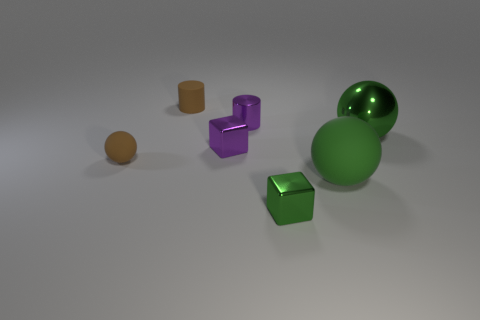Do the green cube and the green matte ball have the same size?
Give a very brief answer. No. Are there any purple shiny cylinders on the left side of the brown matte sphere?
Your response must be concise. No. There is a thing that is both in front of the small matte ball and left of the big green rubber thing; what size is it?
Your answer should be compact. Small. How many objects are brown cylinders or tiny purple objects?
Ensure brevity in your answer.  3. There is a purple metallic cylinder; is its size the same as the brown rubber object in front of the big shiny object?
Give a very brief answer. Yes. There is a matte thing that is behind the ball left of the purple metal object that is in front of the small metal cylinder; how big is it?
Give a very brief answer. Small. Is there a small green rubber cylinder?
Ensure brevity in your answer.  No. What material is the large object that is the same color as the metallic sphere?
Your answer should be compact. Rubber. How many big matte spheres have the same color as the tiny rubber cylinder?
Give a very brief answer. 0. What number of things are tiny shiny objects on the left side of the green metal cube or tiny brown rubber objects that are behind the large green metallic thing?
Your response must be concise. 3. 